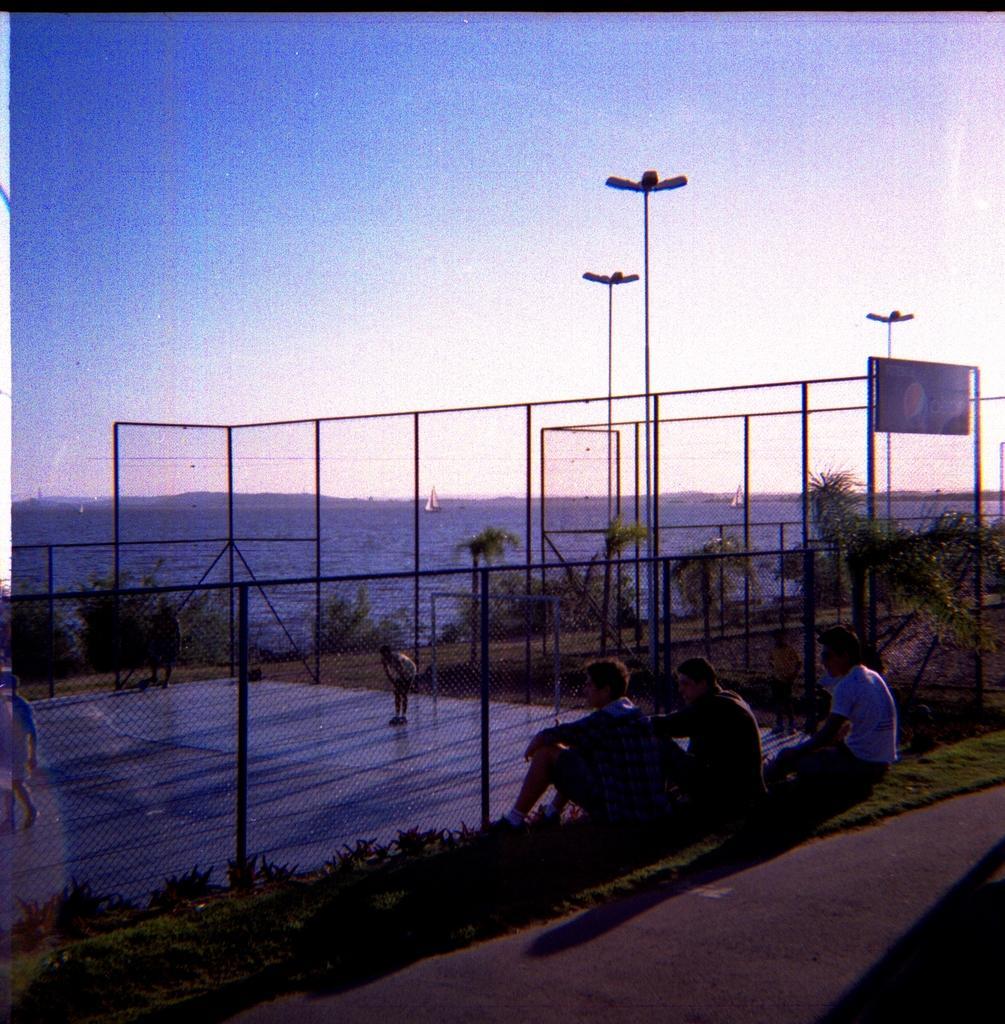In one or two sentences, can you explain what this image depicts? This picture shows few people seated on the grass and we see pole lights and we see few boats on the water and a cloudy sky and we see trees and a metal fence around. 